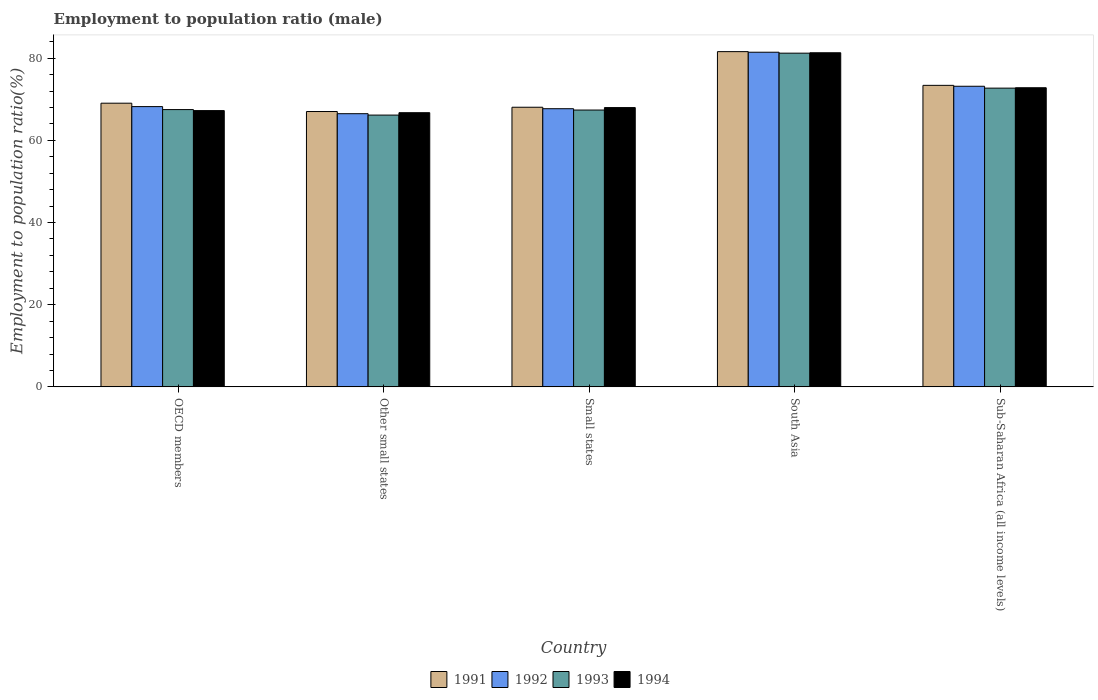How many different coloured bars are there?
Provide a short and direct response. 4. How many groups of bars are there?
Your answer should be compact. 5. Are the number of bars on each tick of the X-axis equal?
Your answer should be very brief. Yes. How many bars are there on the 2nd tick from the left?
Keep it short and to the point. 4. How many bars are there on the 4th tick from the right?
Make the answer very short. 4. What is the employment to population ratio in 1992 in Small states?
Ensure brevity in your answer.  67.7. Across all countries, what is the maximum employment to population ratio in 1991?
Give a very brief answer. 81.6. Across all countries, what is the minimum employment to population ratio in 1992?
Keep it short and to the point. 66.49. In which country was the employment to population ratio in 1993 maximum?
Keep it short and to the point. South Asia. In which country was the employment to population ratio in 1993 minimum?
Your answer should be compact. Other small states. What is the total employment to population ratio in 1993 in the graph?
Provide a short and direct response. 354.96. What is the difference between the employment to population ratio in 1992 in South Asia and that in Sub-Saharan Africa (all income levels)?
Your answer should be compact. 8.28. What is the difference between the employment to population ratio in 1993 in Small states and the employment to population ratio in 1994 in South Asia?
Your answer should be very brief. -13.94. What is the average employment to population ratio in 1993 per country?
Ensure brevity in your answer.  70.99. What is the difference between the employment to population ratio of/in 1993 and employment to population ratio of/in 1994 in Small states?
Provide a short and direct response. -0.6. What is the ratio of the employment to population ratio in 1994 in Other small states to that in Sub-Saharan Africa (all income levels)?
Give a very brief answer. 0.92. Is the difference between the employment to population ratio in 1993 in OECD members and Sub-Saharan Africa (all income levels) greater than the difference between the employment to population ratio in 1994 in OECD members and Sub-Saharan Africa (all income levels)?
Make the answer very short. Yes. What is the difference between the highest and the second highest employment to population ratio in 1991?
Keep it short and to the point. -8.21. What is the difference between the highest and the lowest employment to population ratio in 1994?
Give a very brief answer. 14.59. Is the sum of the employment to population ratio in 1994 in South Asia and Sub-Saharan Africa (all income levels) greater than the maximum employment to population ratio in 1993 across all countries?
Ensure brevity in your answer.  Yes. Is it the case that in every country, the sum of the employment to population ratio in 1991 and employment to population ratio in 1993 is greater than the sum of employment to population ratio in 1994 and employment to population ratio in 1992?
Provide a succinct answer. No. What does the 3rd bar from the left in South Asia represents?
Offer a very short reply. 1993. Is it the case that in every country, the sum of the employment to population ratio in 1994 and employment to population ratio in 1993 is greater than the employment to population ratio in 1991?
Give a very brief answer. Yes. How many countries are there in the graph?
Offer a terse response. 5. Does the graph contain grids?
Ensure brevity in your answer.  No. Where does the legend appear in the graph?
Your response must be concise. Bottom center. How are the legend labels stacked?
Ensure brevity in your answer.  Horizontal. What is the title of the graph?
Provide a succinct answer. Employment to population ratio (male). What is the label or title of the X-axis?
Provide a succinct answer. Country. What is the label or title of the Y-axis?
Keep it short and to the point. Employment to population ratio(%). What is the Employment to population ratio(%) in 1991 in OECD members?
Provide a succinct answer. 69.04. What is the Employment to population ratio(%) of 1992 in OECD members?
Make the answer very short. 68.22. What is the Employment to population ratio(%) of 1993 in OECD members?
Ensure brevity in your answer.  67.49. What is the Employment to population ratio(%) in 1994 in OECD members?
Provide a succinct answer. 67.24. What is the Employment to population ratio(%) of 1991 in Other small states?
Your answer should be compact. 67.02. What is the Employment to population ratio(%) in 1992 in Other small states?
Make the answer very short. 66.49. What is the Employment to population ratio(%) of 1993 in Other small states?
Your answer should be compact. 66.15. What is the Employment to population ratio(%) in 1994 in Other small states?
Offer a terse response. 66.73. What is the Employment to population ratio(%) in 1991 in Small states?
Provide a succinct answer. 68.06. What is the Employment to population ratio(%) of 1992 in Small states?
Ensure brevity in your answer.  67.7. What is the Employment to population ratio(%) in 1993 in Small states?
Offer a very short reply. 67.38. What is the Employment to population ratio(%) in 1994 in Small states?
Your answer should be very brief. 67.98. What is the Employment to population ratio(%) in 1991 in South Asia?
Make the answer very short. 81.6. What is the Employment to population ratio(%) of 1992 in South Asia?
Your response must be concise. 81.45. What is the Employment to population ratio(%) in 1993 in South Asia?
Ensure brevity in your answer.  81.23. What is the Employment to population ratio(%) in 1994 in South Asia?
Make the answer very short. 81.32. What is the Employment to population ratio(%) in 1991 in Sub-Saharan Africa (all income levels)?
Make the answer very short. 73.39. What is the Employment to population ratio(%) in 1992 in Sub-Saharan Africa (all income levels)?
Ensure brevity in your answer.  73.17. What is the Employment to population ratio(%) in 1993 in Sub-Saharan Africa (all income levels)?
Give a very brief answer. 72.71. What is the Employment to population ratio(%) of 1994 in Sub-Saharan Africa (all income levels)?
Make the answer very short. 72.81. Across all countries, what is the maximum Employment to population ratio(%) of 1991?
Offer a very short reply. 81.6. Across all countries, what is the maximum Employment to population ratio(%) of 1992?
Make the answer very short. 81.45. Across all countries, what is the maximum Employment to population ratio(%) of 1993?
Make the answer very short. 81.23. Across all countries, what is the maximum Employment to population ratio(%) in 1994?
Keep it short and to the point. 81.32. Across all countries, what is the minimum Employment to population ratio(%) in 1991?
Offer a terse response. 67.02. Across all countries, what is the minimum Employment to population ratio(%) of 1992?
Your response must be concise. 66.49. Across all countries, what is the minimum Employment to population ratio(%) of 1993?
Offer a very short reply. 66.15. Across all countries, what is the minimum Employment to population ratio(%) in 1994?
Offer a terse response. 66.73. What is the total Employment to population ratio(%) of 1991 in the graph?
Offer a very short reply. 359.11. What is the total Employment to population ratio(%) in 1992 in the graph?
Ensure brevity in your answer.  357.04. What is the total Employment to population ratio(%) of 1993 in the graph?
Ensure brevity in your answer.  354.96. What is the total Employment to population ratio(%) in 1994 in the graph?
Ensure brevity in your answer.  356.09. What is the difference between the Employment to population ratio(%) of 1991 in OECD members and that in Other small states?
Keep it short and to the point. 2.03. What is the difference between the Employment to population ratio(%) of 1992 in OECD members and that in Other small states?
Give a very brief answer. 1.73. What is the difference between the Employment to population ratio(%) of 1993 in OECD members and that in Other small states?
Your answer should be very brief. 1.34. What is the difference between the Employment to population ratio(%) of 1994 in OECD members and that in Other small states?
Ensure brevity in your answer.  0.51. What is the difference between the Employment to population ratio(%) of 1991 in OECD members and that in Small states?
Provide a succinct answer. 0.98. What is the difference between the Employment to population ratio(%) in 1992 in OECD members and that in Small states?
Your answer should be very brief. 0.52. What is the difference between the Employment to population ratio(%) of 1993 in OECD members and that in Small states?
Offer a very short reply. 0.11. What is the difference between the Employment to population ratio(%) of 1994 in OECD members and that in Small states?
Offer a very short reply. -0.73. What is the difference between the Employment to population ratio(%) in 1991 in OECD members and that in South Asia?
Provide a succinct answer. -12.55. What is the difference between the Employment to population ratio(%) in 1992 in OECD members and that in South Asia?
Give a very brief answer. -13.23. What is the difference between the Employment to population ratio(%) in 1993 in OECD members and that in South Asia?
Offer a very short reply. -13.73. What is the difference between the Employment to population ratio(%) of 1994 in OECD members and that in South Asia?
Offer a terse response. -14.08. What is the difference between the Employment to population ratio(%) of 1991 in OECD members and that in Sub-Saharan Africa (all income levels)?
Make the answer very short. -4.34. What is the difference between the Employment to population ratio(%) of 1992 in OECD members and that in Sub-Saharan Africa (all income levels)?
Give a very brief answer. -4.95. What is the difference between the Employment to population ratio(%) in 1993 in OECD members and that in Sub-Saharan Africa (all income levels)?
Your answer should be very brief. -5.22. What is the difference between the Employment to population ratio(%) in 1994 in OECD members and that in Sub-Saharan Africa (all income levels)?
Ensure brevity in your answer.  -5.56. What is the difference between the Employment to population ratio(%) in 1991 in Other small states and that in Small states?
Your response must be concise. -1.04. What is the difference between the Employment to population ratio(%) in 1992 in Other small states and that in Small states?
Provide a succinct answer. -1.21. What is the difference between the Employment to population ratio(%) in 1993 in Other small states and that in Small states?
Offer a very short reply. -1.23. What is the difference between the Employment to population ratio(%) of 1994 in Other small states and that in Small states?
Offer a terse response. -1.25. What is the difference between the Employment to population ratio(%) in 1991 in Other small states and that in South Asia?
Your answer should be compact. -14.58. What is the difference between the Employment to population ratio(%) in 1992 in Other small states and that in South Asia?
Your answer should be compact. -14.96. What is the difference between the Employment to population ratio(%) in 1993 in Other small states and that in South Asia?
Provide a succinct answer. -15.07. What is the difference between the Employment to population ratio(%) in 1994 in Other small states and that in South Asia?
Offer a terse response. -14.59. What is the difference between the Employment to population ratio(%) of 1991 in Other small states and that in Sub-Saharan Africa (all income levels)?
Keep it short and to the point. -6.37. What is the difference between the Employment to population ratio(%) in 1992 in Other small states and that in Sub-Saharan Africa (all income levels)?
Give a very brief answer. -6.68. What is the difference between the Employment to population ratio(%) of 1993 in Other small states and that in Sub-Saharan Africa (all income levels)?
Keep it short and to the point. -6.56. What is the difference between the Employment to population ratio(%) of 1994 in Other small states and that in Sub-Saharan Africa (all income levels)?
Your answer should be compact. -6.08. What is the difference between the Employment to population ratio(%) in 1991 in Small states and that in South Asia?
Your answer should be compact. -13.54. What is the difference between the Employment to population ratio(%) in 1992 in Small states and that in South Asia?
Your answer should be compact. -13.75. What is the difference between the Employment to population ratio(%) in 1993 in Small states and that in South Asia?
Keep it short and to the point. -13.84. What is the difference between the Employment to population ratio(%) of 1994 in Small states and that in South Asia?
Offer a terse response. -13.34. What is the difference between the Employment to population ratio(%) of 1991 in Small states and that in Sub-Saharan Africa (all income levels)?
Provide a succinct answer. -5.33. What is the difference between the Employment to population ratio(%) in 1992 in Small states and that in Sub-Saharan Africa (all income levels)?
Offer a very short reply. -5.47. What is the difference between the Employment to population ratio(%) of 1993 in Small states and that in Sub-Saharan Africa (all income levels)?
Your answer should be compact. -5.33. What is the difference between the Employment to population ratio(%) of 1994 in Small states and that in Sub-Saharan Africa (all income levels)?
Offer a terse response. -4.83. What is the difference between the Employment to population ratio(%) in 1991 in South Asia and that in Sub-Saharan Africa (all income levels)?
Give a very brief answer. 8.21. What is the difference between the Employment to population ratio(%) of 1992 in South Asia and that in Sub-Saharan Africa (all income levels)?
Provide a succinct answer. 8.28. What is the difference between the Employment to population ratio(%) of 1993 in South Asia and that in Sub-Saharan Africa (all income levels)?
Your response must be concise. 8.51. What is the difference between the Employment to population ratio(%) of 1994 in South Asia and that in Sub-Saharan Africa (all income levels)?
Provide a short and direct response. 8.51. What is the difference between the Employment to population ratio(%) of 1991 in OECD members and the Employment to population ratio(%) of 1992 in Other small states?
Your answer should be very brief. 2.55. What is the difference between the Employment to population ratio(%) of 1991 in OECD members and the Employment to population ratio(%) of 1993 in Other small states?
Provide a short and direct response. 2.89. What is the difference between the Employment to population ratio(%) in 1991 in OECD members and the Employment to population ratio(%) in 1994 in Other small states?
Give a very brief answer. 2.31. What is the difference between the Employment to population ratio(%) in 1992 in OECD members and the Employment to population ratio(%) in 1993 in Other small states?
Offer a very short reply. 2.07. What is the difference between the Employment to population ratio(%) of 1992 in OECD members and the Employment to population ratio(%) of 1994 in Other small states?
Your answer should be very brief. 1.49. What is the difference between the Employment to population ratio(%) in 1993 in OECD members and the Employment to population ratio(%) in 1994 in Other small states?
Your answer should be compact. 0.76. What is the difference between the Employment to population ratio(%) of 1991 in OECD members and the Employment to population ratio(%) of 1992 in Small states?
Your answer should be compact. 1.34. What is the difference between the Employment to population ratio(%) in 1991 in OECD members and the Employment to population ratio(%) in 1993 in Small states?
Give a very brief answer. 1.66. What is the difference between the Employment to population ratio(%) in 1991 in OECD members and the Employment to population ratio(%) in 1994 in Small states?
Your response must be concise. 1.07. What is the difference between the Employment to population ratio(%) in 1992 in OECD members and the Employment to population ratio(%) in 1993 in Small states?
Provide a short and direct response. 0.84. What is the difference between the Employment to population ratio(%) of 1992 in OECD members and the Employment to population ratio(%) of 1994 in Small states?
Keep it short and to the point. 0.24. What is the difference between the Employment to population ratio(%) of 1993 in OECD members and the Employment to population ratio(%) of 1994 in Small states?
Your answer should be compact. -0.49. What is the difference between the Employment to population ratio(%) of 1991 in OECD members and the Employment to population ratio(%) of 1992 in South Asia?
Offer a terse response. -12.41. What is the difference between the Employment to population ratio(%) of 1991 in OECD members and the Employment to population ratio(%) of 1993 in South Asia?
Make the answer very short. -12.18. What is the difference between the Employment to population ratio(%) of 1991 in OECD members and the Employment to population ratio(%) of 1994 in South Asia?
Offer a terse response. -12.28. What is the difference between the Employment to population ratio(%) of 1992 in OECD members and the Employment to population ratio(%) of 1993 in South Asia?
Your answer should be very brief. -13.01. What is the difference between the Employment to population ratio(%) in 1992 in OECD members and the Employment to population ratio(%) in 1994 in South Asia?
Provide a succinct answer. -13.1. What is the difference between the Employment to population ratio(%) of 1993 in OECD members and the Employment to population ratio(%) of 1994 in South Asia?
Make the answer very short. -13.83. What is the difference between the Employment to population ratio(%) of 1991 in OECD members and the Employment to population ratio(%) of 1992 in Sub-Saharan Africa (all income levels)?
Make the answer very short. -4.12. What is the difference between the Employment to population ratio(%) in 1991 in OECD members and the Employment to population ratio(%) in 1993 in Sub-Saharan Africa (all income levels)?
Provide a succinct answer. -3.67. What is the difference between the Employment to population ratio(%) of 1991 in OECD members and the Employment to population ratio(%) of 1994 in Sub-Saharan Africa (all income levels)?
Provide a short and direct response. -3.76. What is the difference between the Employment to population ratio(%) of 1992 in OECD members and the Employment to population ratio(%) of 1993 in Sub-Saharan Africa (all income levels)?
Provide a short and direct response. -4.5. What is the difference between the Employment to population ratio(%) of 1992 in OECD members and the Employment to population ratio(%) of 1994 in Sub-Saharan Africa (all income levels)?
Give a very brief answer. -4.59. What is the difference between the Employment to population ratio(%) in 1993 in OECD members and the Employment to population ratio(%) in 1994 in Sub-Saharan Africa (all income levels)?
Provide a succinct answer. -5.32. What is the difference between the Employment to population ratio(%) in 1991 in Other small states and the Employment to population ratio(%) in 1992 in Small states?
Offer a terse response. -0.68. What is the difference between the Employment to population ratio(%) in 1991 in Other small states and the Employment to population ratio(%) in 1993 in Small states?
Your answer should be very brief. -0.36. What is the difference between the Employment to population ratio(%) of 1991 in Other small states and the Employment to population ratio(%) of 1994 in Small states?
Offer a terse response. -0.96. What is the difference between the Employment to population ratio(%) in 1992 in Other small states and the Employment to population ratio(%) in 1993 in Small states?
Offer a terse response. -0.89. What is the difference between the Employment to population ratio(%) of 1992 in Other small states and the Employment to population ratio(%) of 1994 in Small states?
Offer a terse response. -1.49. What is the difference between the Employment to population ratio(%) in 1993 in Other small states and the Employment to population ratio(%) in 1994 in Small states?
Offer a very short reply. -1.83. What is the difference between the Employment to population ratio(%) of 1991 in Other small states and the Employment to population ratio(%) of 1992 in South Asia?
Provide a short and direct response. -14.43. What is the difference between the Employment to population ratio(%) in 1991 in Other small states and the Employment to population ratio(%) in 1993 in South Asia?
Your answer should be very brief. -14.21. What is the difference between the Employment to population ratio(%) in 1991 in Other small states and the Employment to population ratio(%) in 1994 in South Asia?
Offer a terse response. -14.3. What is the difference between the Employment to population ratio(%) in 1992 in Other small states and the Employment to population ratio(%) in 1993 in South Asia?
Give a very brief answer. -14.73. What is the difference between the Employment to population ratio(%) in 1992 in Other small states and the Employment to population ratio(%) in 1994 in South Asia?
Offer a very short reply. -14.83. What is the difference between the Employment to population ratio(%) of 1993 in Other small states and the Employment to population ratio(%) of 1994 in South Asia?
Ensure brevity in your answer.  -15.17. What is the difference between the Employment to population ratio(%) in 1991 in Other small states and the Employment to population ratio(%) in 1992 in Sub-Saharan Africa (all income levels)?
Offer a very short reply. -6.15. What is the difference between the Employment to population ratio(%) of 1991 in Other small states and the Employment to population ratio(%) of 1993 in Sub-Saharan Africa (all income levels)?
Your answer should be very brief. -5.69. What is the difference between the Employment to population ratio(%) of 1991 in Other small states and the Employment to population ratio(%) of 1994 in Sub-Saharan Africa (all income levels)?
Your response must be concise. -5.79. What is the difference between the Employment to population ratio(%) of 1992 in Other small states and the Employment to population ratio(%) of 1993 in Sub-Saharan Africa (all income levels)?
Offer a terse response. -6.22. What is the difference between the Employment to population ratio(%) in 1992 in Other small states and the Employment to population ratio(%) in 1994 in Sub-Saharan Africa (all income levels)?
Give a very brief answer. -6.32. What is the difference between the Employment to population ratio(%) of 1993 in Other small states and the Employment to population ratio(%) of 1994 in Sub-Saharan Africa (all income levels)?
Make the answer very short. -6.66. What is the difference between the Employment to population ratio(%) in 1991 in Small states and the Employment to population ratio(%) in 1992 in South Asia?
Make the answer very short. -13.39. What is the difference between the Employment to population ratio(%) in 1991 in Small states and the Employment to population ratio(%) in 1993 in South Asia?
Provide a short and direct response. -13.17. What is the difference between the Employment to population ratio(%) of 1991 in Small states and the Employment to population ratio(%) of 1994 in South Asia?
Keep it short and to the point. -13.26. What is the difference between the Employment to population ratio(%) in 1992 in Small states and the Employment to population ratio(%) in 1993 in South Asia?
Your answer should be very brief. -13.52. What is the difference between the Employment to population ratio(%) of 1992 in Small states and the Employment to population ratio(%) of 1994 in South Asia?
Give a very brief answer. -13.62. What is the difference between the Employment to population ratio(%) of 1993 in Small states and the Employment to population ratio(%) of 1994 in South Asia?
Keep it short and to the point. -13.94. What is the difference between the Employment to population ratio(%) of 1991 in Small states and the Employment to population ratio(%) of 1992 in Sub-Saharan Africa (all income levels)?
Your response must be concise. -5.11. What is the difference between the Employment to population ratio(%) in 1991 in Small states and the Employment to population ratio(%) in 1993 in Sub-Saharan Africa (all income levels)?
Provide a short and direct response. -4.65. What is the difference between the Employment to population ratio(%) in 1991 in Small states and the Employment to population ratio(%) in 1994 in Sub-Saharan Africa (all income levels)?
Ensure brevity in your answer.  -4.75. What is the difference between the Employment to population ratio(%) of 1992 in Small states and the Employment to population ratio(%) of 1993 in Sub-Saharan Africa (all income levels)?
Your answer should be compact. -5.01. What is the difference between the Employment to population ratio(%) in 1992 in Small states and the Employment to population ratio(%) in 1994 in Sub-Saharan Africa (all income levels)?
Keep it short and to the point. -5.11. What is the difference between the Employment to population ratio(%) in 1993 in Small states and the Employment to population ratio(%) in 1994 in Sub-Saharan Africa (all income levels)?
Make the answer very short. -5.43. What is the difference between the Employment to population ratio(%) in 1991 in South Asia and the Employment to population ratio(%) in 1992 in Sub-Saharan Africa (all income levels)?
Give a very brief answer. 8.43. What is the difference between the Employment to population ratio(%) in 1991 in South Asia and the Employment to population ratio(%) in 1993 in Sub-Saharan Africa (all income levels)?
Offer a terse response. 8.88. What is the difference between the Employment to population ratio(%) in 1991 in South Asia and the Employment to population ratio(%) in 1994 in Sub-Saharan Africa (all income levels)?
Provide a succinct answer. 8.79. What is the difference between the Employment to population ratio(%) in 1992 in South Asia and the Employment to population ratio(%) in 1993 in Sub-Saharan Africa (all income levels)?
Your answer should be compact. 8.74. What is the difference between the Employment to population ratio(%) in 1992 in South Asia and the Employment to population ratio(%) in 1994 in Sub-Saharan Africa (all income levels)?
Your response must be concise. 8.64. What is the difference between the Employment to population ratio(%) in 1993 in South Asia and the Employment to population ratio(%) in 1994 in Sub-Saharan Africa (all income levels)?
Your answer should be compact. 8.42. What is the average Employment to population ratio(%) in 1991 per country?
Make the answer very short. 71.82. What is the average Employment to population ratio(%) of 1992 per country?
Keep it short and to the point. 71.41. What is the average Employment to population ratio(%) of 1993 per country?
Ensure brevity in your answer.  70.99. What is the average Employment to population ratio(%) in 1994 per country?
Ensure brevity in your answer.  71.22. What is the difference between the Employment to population ratio(%) in 1991 and Employment to population ratio(%) in 1992 in OECD members?
Keep it short and to the point. 0.83. What is the difference between the Employment to population ratio(%) in 1991 and Employment to population ratio(%) in 1993 in OECD members?
Offer a terse response. 1.55. What is the difference between the Employment to population ratio(%) in 1991 and Employment to population ratio(%) in 1994 in OECD members?
Your response must be concise. 1.8. What is the difference between the Employment to population ratio(%) of 1992 and Employment to population ratio(%) of 1993 in OECD members?
Ensure brevity in your answer.  0.73. What is the difference between the Employment to population ratio(%) in 1992 and Employment to population ratio(%) in 1994 in OECD members?
Provide a short and direct response. 0.97. What is the difference between the Employment to population ratio(%) in 1993 and Employment to population ratio(%) in 1994 in OECD members?
Your response must be concise. 0.25. What is the difference between the Employment to population ratio(%) in 1991 and Employment to population ratio(%) in 1992 in Other small states?
Your response must be concise. 0.53. What is the difference between the Employment to population ratio(%) in 1991 and Employment to population ratio(%) in 1993 in Other small states?
Provide a succinct answer. 0.87. What is the difference between the Employment to population ratio(%) in 1991 and Employment to population ratio(%) in 1994 in Other small states?
Your answer should be compact. 0.29. What is the difference between the Employment to population ratio(%) in 1992 and Employment to population ratio(%) in 1993 in Other small states?
Provide a succinct answer. 0.34. What is the difference between the Employment to population ratio(%) of 1992 and Employment to population ratio(%) of 1994 in Other small states?
Provide a succinct answer. -0.24. What is the difference between the Employment to population ratio(%) in 1993 and Employment to population ratio(%) in 1994 in Other small states?
Ensure brevity in your answer.  -0.58. What is the difference between the Employment to population ratio(%) of 1991 and Employment to population ratio(%) of 1992 in Small states?
Offer a very short reply. 0.36. What is the difference between the Employment to population ratio(%) in 1991 and Employment to population ratio(%) in 1993 in Small states?
Provide a succinct answer. 0.68. What is the difference between the Employment to population ratio(%) in 1991 and Employment to population ratio(%) in 1994 in Small states?
Provide a succinct answer. 0.08. What is the difference between the Employment to population ratio(%) in 1992 and Employment to population ratio(%) in 1993 in Small states?
Provide a short and direct response. 0.32. What is the difference between the Employment to population ratio(%) of 1992 and Employment to population ratio(%) of 1994 in Small states?
Give a very brief answer. -0.28. What is the difference between the Employment to population ratio(%) in 1993 and Employment to population ratio(%) in 1994 in Small states?
Make the answer very short. -0.6. What is the difference between the Employment to population ratio(%) in 1991 and Employment to population ratio(%) in 1992 in South Asia?
Give a very brief answer. 0.14. What is the difference between the Employment to population ratio(%) in 1991 and Employment to population ratio(%) in 1993 in South Asia?
Offer a terse response. 0.37. What is the difference between the Employment to population ratio(%) of 1991 and Employment to population ratio(%) of 1994 in South Asia?
Offer a terse response. 0.27. What is the difference between the Employment to population ratio(%) in 1992 and Employment to population ratio(%) in 1993 in South Asia?
Your answer should be very brief. 0.23. What is the difference between the Employment to population ratio(%) in 1992 and Employment to population ratio(%) in 1994 in South Asia?
Ensure brevity in your answer.  0.13. What is the difference between the Employment to population ratio(%) of 1993 and Employment to population ratio(%) of 1994 in South Asia?
Ensure brevity in your answer.  -0.1. What is the difference between the Employment to population ratio(%) of 1991 and Employment to population ratio(%) of 1992 in Sub-Saharan Africa (all income levels)?
Your answer should be very brief. 0.22. What is the difference between the Employment to population ratio(%) of 1991 and Employment to population ratio(%) of 1993 in Sub-Saharan Africa (all income levels)?
Give a very brief answer. 0.67. What is the difference between the Employment to population ratio(%) of 1991 and Employment to population ratio(%) of 1994 in Sub-Saharan Africa (all income levels)?
Your response must be concise. 0.58. What is the difference between the Employment to population ratio(%) in 1992 and Employment to population ratio(%) in 1993 in Sub-Saharan Africa (all income levels)?
Your answer should be very brief. 0.45. What is the difference between the Employment to population ratio(%) in 1992 and Employment to population ratio(%) in 1994 in Sub-Saharan Africa (all income levels)?
Keep it short and to the point. 0.36. What is the difference between the Employment to population ratio(%) of 1993 and Employment to population ratio(%) of 1994 in Sub-Saharan Africa (all income levels)?
Provide a short and direct response. -0.09. What is the ratio of the Employment to population ratio(%) in 1991 in OECD members to that in Other small states?
Provide a succinct answer. 1.03. What is the ratio of the Employment to population ratio(%) in 1993 in OECD members to that in Other small states?
Provide a succinct answer. 1.02. What is the ratio of the Employment to population ratio(%) in 1994 in OECD members to that in Other small states?
Your response must be concise. 1.01. What is the ratio of the Employment to population ratio(%) in 1991 in OECD members to that in Small states?
Offer a very short reply. 1.01. What is the ratio of the Employment to population ratio(%) of 1992 in OECD members to that in Small states?
Your response must be concise. 1.01. What is the ratio of the Employment to population ratio(%) in 1994 in OECD members to that in Small states?
Offer a very short reply. 0.99. What is the ratio of the Employment to population ratio(%) of 1991 in OECD members to that in South Asia?
Your response must be concise. 0.85. What is the ratio of the Employment to population ratio(%) of 1992 in OECD members to that in South Asia?
Ensure brevity in your answer.  0.84. What is the ratio of the Employment to population ratio(%) in 1993 in OECD members to that in South Asia?
Your answer should be compact. 0.83. What is the ratio of the Employment to population ratio(%) of 1994 in OECD members to that in South Asia?
Provide a short and direct response. 0.83. What is the ratio of the Employment to population ratio(%) of 1991 in OECD members to that in Sub-Saharan Africa (all income levels)?
Ensure brevity in your answer.  0.94. What is the ratio of the Employment to population ratio(%) in 1992 in OECD members to that in Sub-Saharan Africa (all income levels)?
Your answer should be compact. 0.93. What is the ratio of the Employment to population ratio(%) in 1993 in OECD members to that in Sub-Saharan Africa (all income levels)?
Offer a terse response. 0.93. What is the ratio of the Employment to population ratio(%) of 1994 in OECD members to that in Sub-Saharan Africa (all income levels)?
Give a very brief answer. 0.92. What is the ratio of the Employment to population ratio(%) in 1991 in Other small states to that in Small states?
Ensure brevity in your answer.  0.98. What is the ratio of the Employment to population ratio(%) of 1992 in Other small states to that in Small states?
Provide a succinct answer. 0.98. What is the ratio of the Employment to population ratio(%) in 1993 in Other small states to that in Small states?
Provide a succinct answer. 0.98. What is the ratio of the Employment to population ratio(%) in 1994 in Other small states to that in Small states?
Offer a terse response. 0.98. What is the ratio of the Employment to population ratio(%) of 1991 in Other small states to that in South Asia?
Provide a short and direct response. 0.82. What is the ratio of the Employment to population ratio(%) of 1992 in Other small states to that in South Asia?
Keep it short and to the point. 0.82. What is the ratio of the Employment to population ratio(%) in 1993 in Other small states to that in South Asia?
Your response must be concise. 0.81. What is the ratio of the Employment to population ratio(%) of 1994 in Other small states to that in South Asia?
Your response must be concise. 0.82. What is the ratio of the Employment to population ratio(%) of 1991 in Other small states to that in Sub-Saharan Africa (all income levels)?
Make the answer very short. 0.91. What is the ratio of the Employment to population ratio(%) of 1992 in Other small states to that in Sub-Saharan Africa (all income levels)?
Your response must be concise. 0.91. What is the ratio of the Employment to population ratio(%) of 1993 in Other small states to that in Sub-Saharan Africa (all income levels)?
Provide a succinct answer. 0.91. What is the ratio of the Employment to population ratio(%) of 1994 in Other small states to that in Sub-Saharan Africa (all income levels)?
Make the answer very short. 0.92. What is the ratio of the Employment to population ratio(%) of 1991 in Small states to that in South Asia?
Offer a very short reply. 0.83. What is the ratio of the Employment to population ratio(%) of 1992 in Small states to that in South Asia?
Your answer should be very brief. 0.83. What is the ratio of the Employment to population ratio(%) in 1993 in Small states to that in South Asia?
Give a very brief answer. 0.83. What is the ratio of the Employment to population ratio(%) of 1994 in Small states to that in South Asia?
Your response must be concise. 0.84. What is the ratio of the Employment to population ratio(%) of 1991 in Small states to that in Sub-Saharan Africa (all income levels)?
Make the answer very short. 0.93. What is the ratio of the Employment to population ratio(%) in 1992 in Small states to that in Sub-Saharan Africa (all income levels)?
Make the answer very short. 0.93. What is the ratio of the Employment to population ratio(%) in 1993 in Small states to that in Sub-Saharan Africa (all income levels)?
Your answer should be very brief. 0.93. What is the ratio of the Employment to population ratio(%) in 1994 in Small states to that in Sub-Saharan Africa (all income levels)?
Make the answer very short. 0.93. What is the ratio of the Employment to population ratio(%) of 1991 in South Asia to that in Sub-Saharan Africa (all income levels)?
Ensure brevity in your answer.  1.11. What is the ratio of the Employment to population ratio(%) in 1992 in South Asia to that in Sub-Saharan Africa (all income levels)?
Your answer should be very brief. 1.11. What is the ratio of the Employment to population ratio(%) in 1993 in South Asia to that in Sub-Saharan Africa (all income levels)?
Provide a short and direct response. 1.12. What is the ratio of the Employment to population ratio(%) in 1994 in South Asia to that in Sub-Saharan Africa (all income levels)?
Your answer should be compact. 1.12. What is the difference between the highest and the second highest Employment to population ratio(%) of 1991?
Keep it short and to the point. 8.21. What is the difference between the highest and the second highest Employment to population ratio(%) of 1992?
Ensure brevity in your answer.  8.28. What is the difference between the highest and the second highest Employment to population ratio(%) in 1993?
Offer a very short reply. 8.51. What is the difference between the highest and the second highest Employment to population ratio(%) in 1994?
Offer a terse response. 8.51. What is the difference between the highest and the lowest Employment to population ratio(%) of 1991?
Keep it short and to the point. 14.58. What is the difference between the highest and the lowest Employment to population ratio(%) of 1992?
Give a very brief answer. 14.96. What is the difference between the highest and the lowest Employment to population ratio(%) of 1993?
Keep it short and to the point. 15.07. What is the difference between the highest and the lowest Employment to population ratio(%) in 1994?
Your answer should be compact. 14.59. 